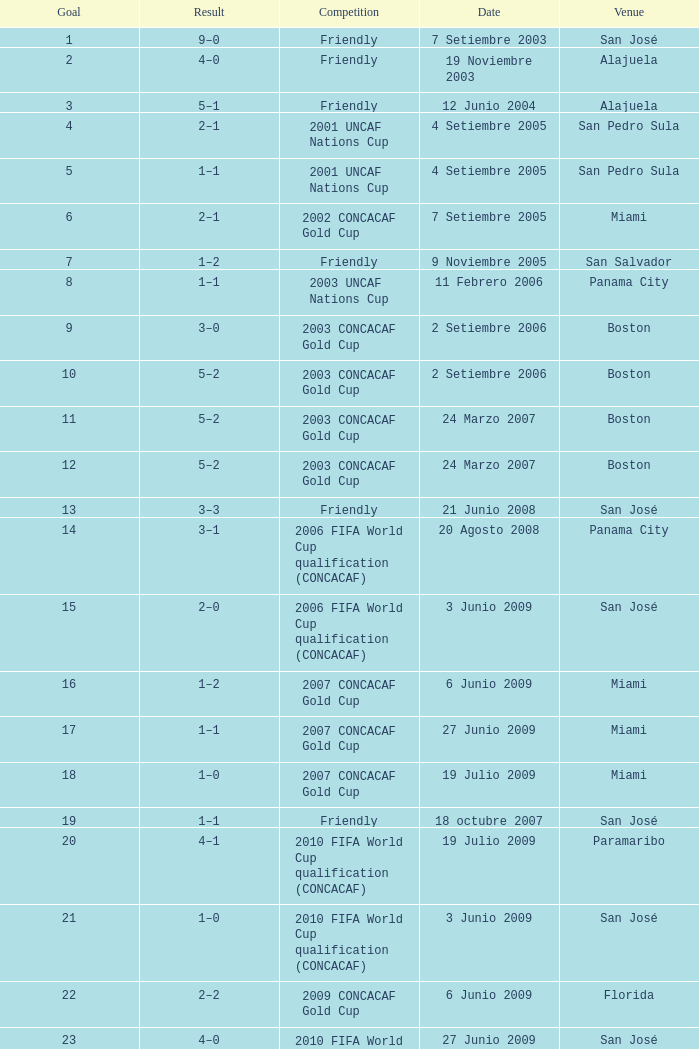At the venue of panama city, on 11 Febrero 2006, how many goals were scored? 1.0. 